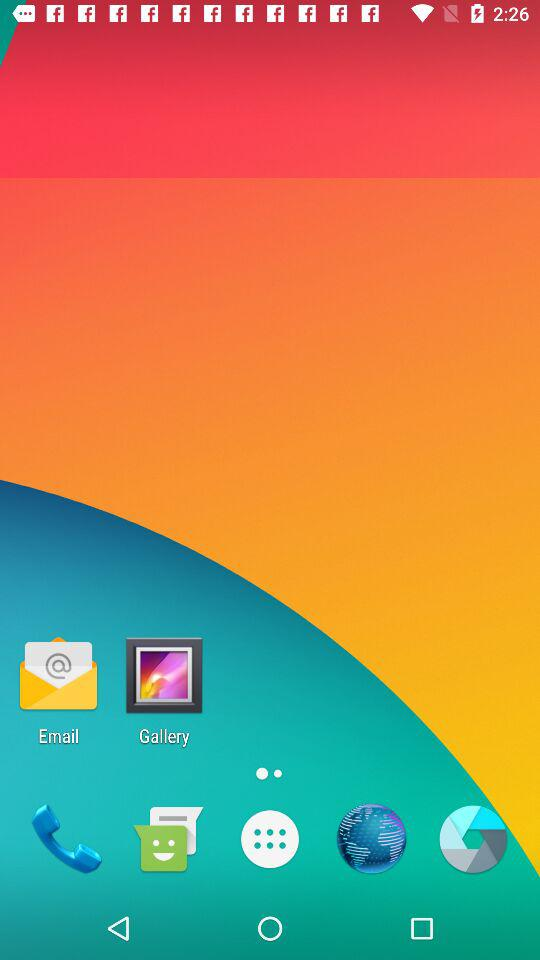What are the options to choose the guide voice engine? The options are "Google Text-to-speech Engine" and "Pico TTS". 